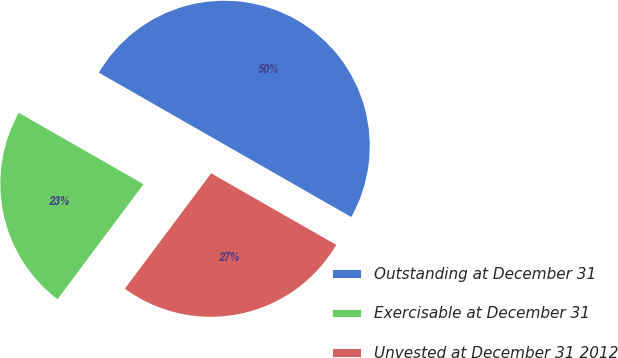Convert chart to OTSL. <chart><loc_0><loc_0><loc_500><loc_500><pie_chart><fcel>Outstanding at December 31<fcel>Exercisable at December 31<fcel>Unvested at December 31 2012<nl><fcel>50.0%<fcel>23.05%<fcel>26.95%<nl></chart> 